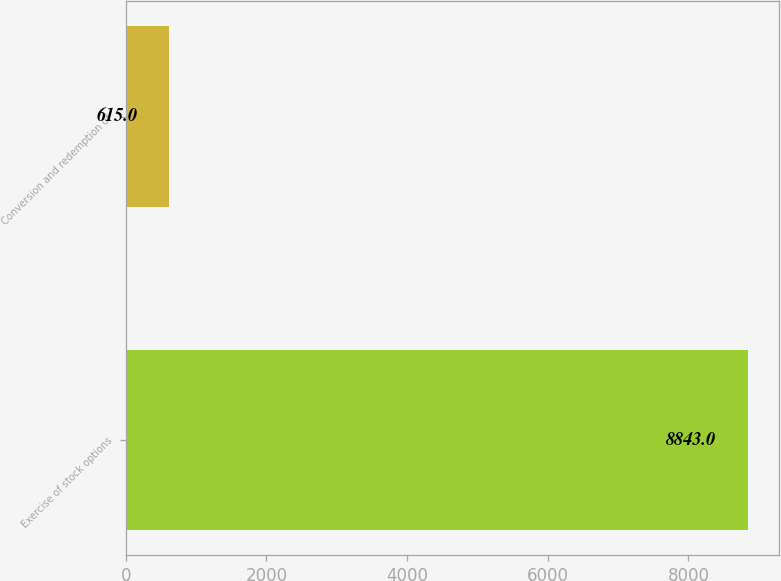Convert chart. <chart><loc_0><loc_0><loc_500><loc_500><bar_chart><fcel>Exercise of stock options<fcel>Conversion and redemption of<nl><fcel>8843<fcel>615<nl></chart> 